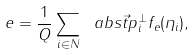Convert formula to latex. <formula><loc_0><loc_0><loc_500><loc_500>e = \frac { 1 } { Q } \sum _ { i \in N } \ a b s { \vec { t } { p } _ { i } ^ { \perp } } f _ { e } ( \eta _ { i } ) ,</formula> 